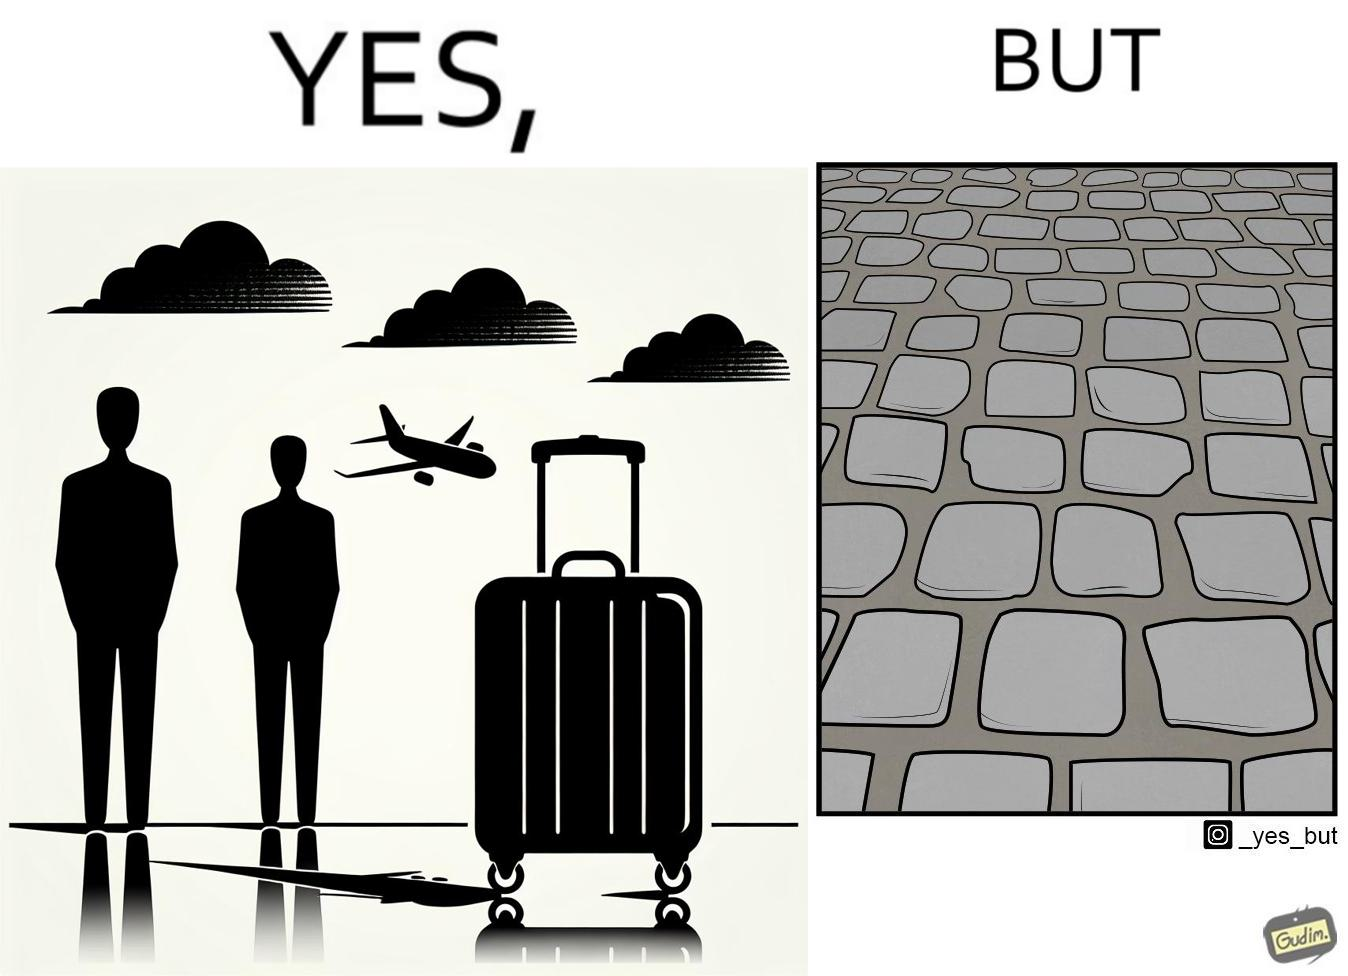Describe what you see in this image. The image is funny because even though the trolley bag is made to make carrying luggage easy, as soon as it encounters a rough surface like cobblestone road, it makes carrying luggage more difficult. 